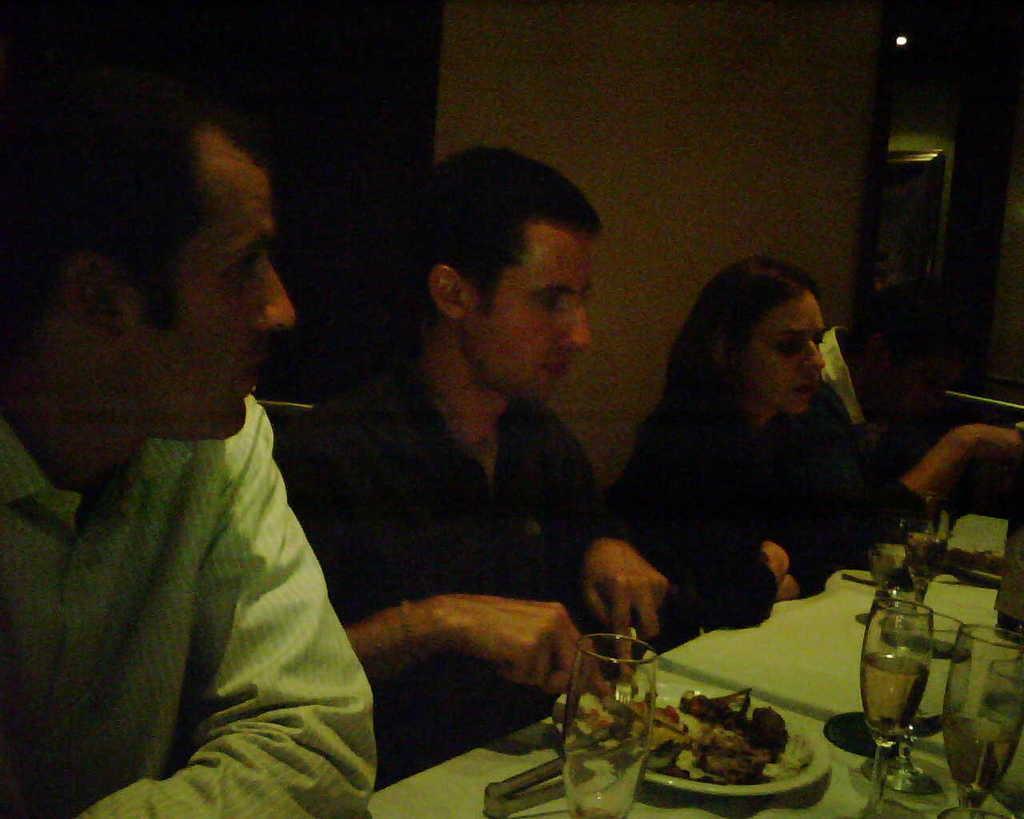In one or two sentences, can you explain what this image depicts? In the image there are three men and a woman sitting in front of dining table with wine glasses. plates,food,fork on it, behind them there is wall. 